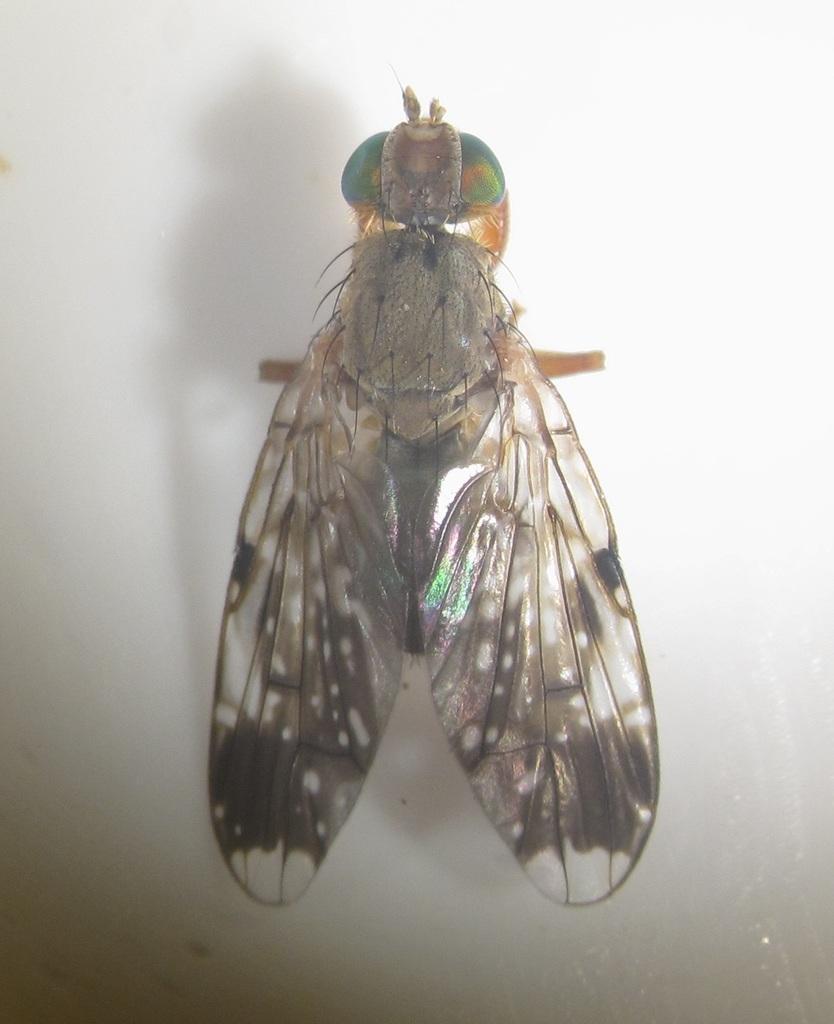Can you describe this image briefly? In this image we can see a housefly on a platform. 